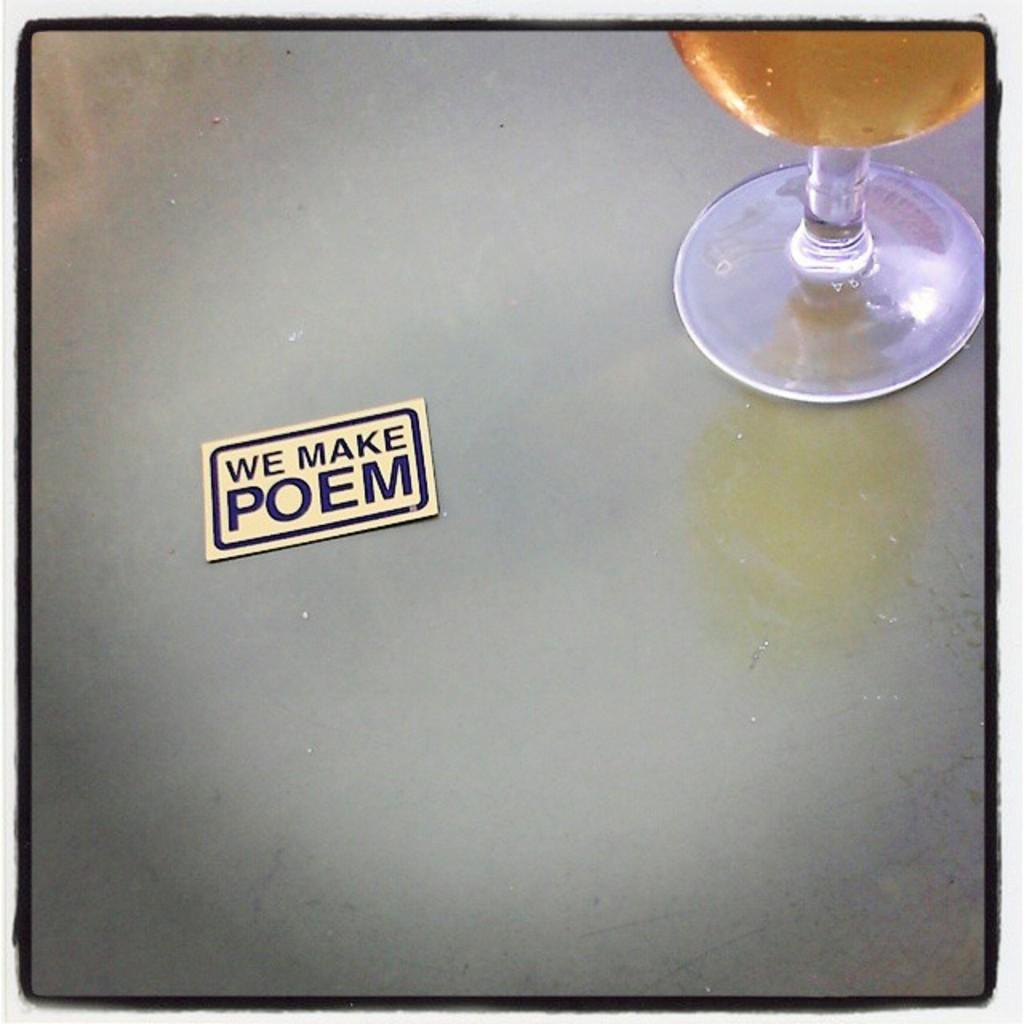Provide a one-sentence caption for the provided image. A card on a table reading We Make Poem. 